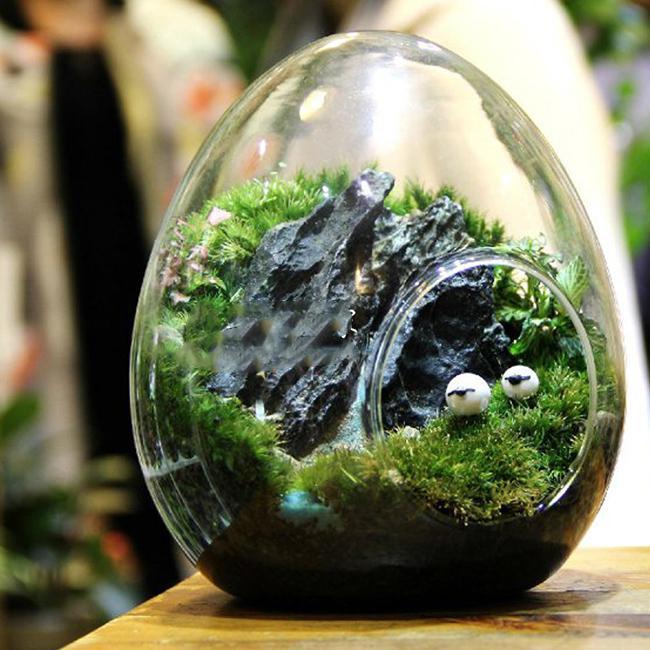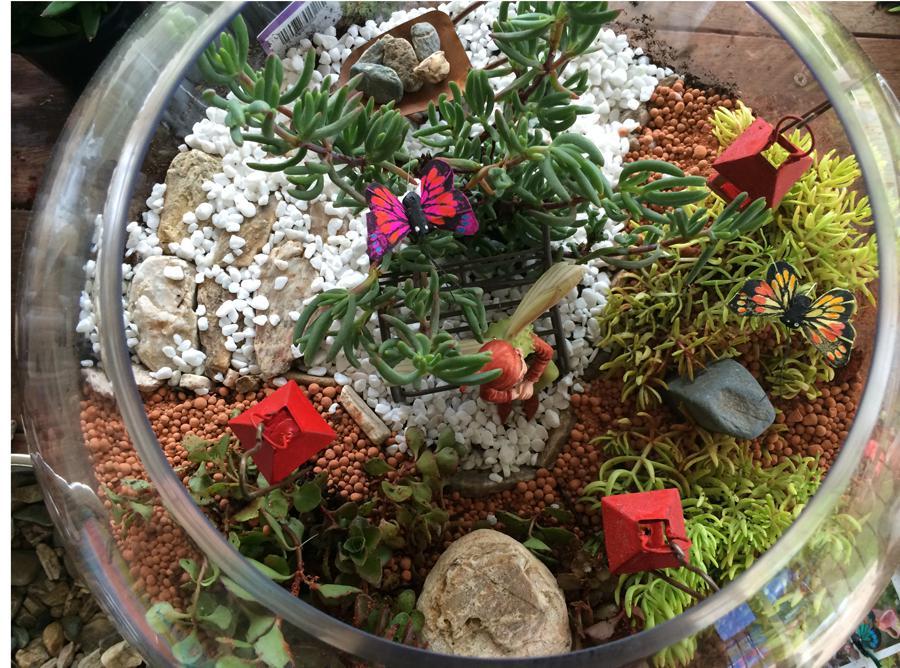The first image is the image on the left, the second image is the image on the right. For the images displayed, is the sentence "In at least on image there is a glass container holding a single sitting female fairy with wings." factually correct? Answer yes or no. No. The first image is the image on the left, the second image is the image on the right. For the images shown, is this caption "The right image features a 'fairy garden' terrarium shaped like a fishbowl on its side." true? Answer yes or no. Yes. 